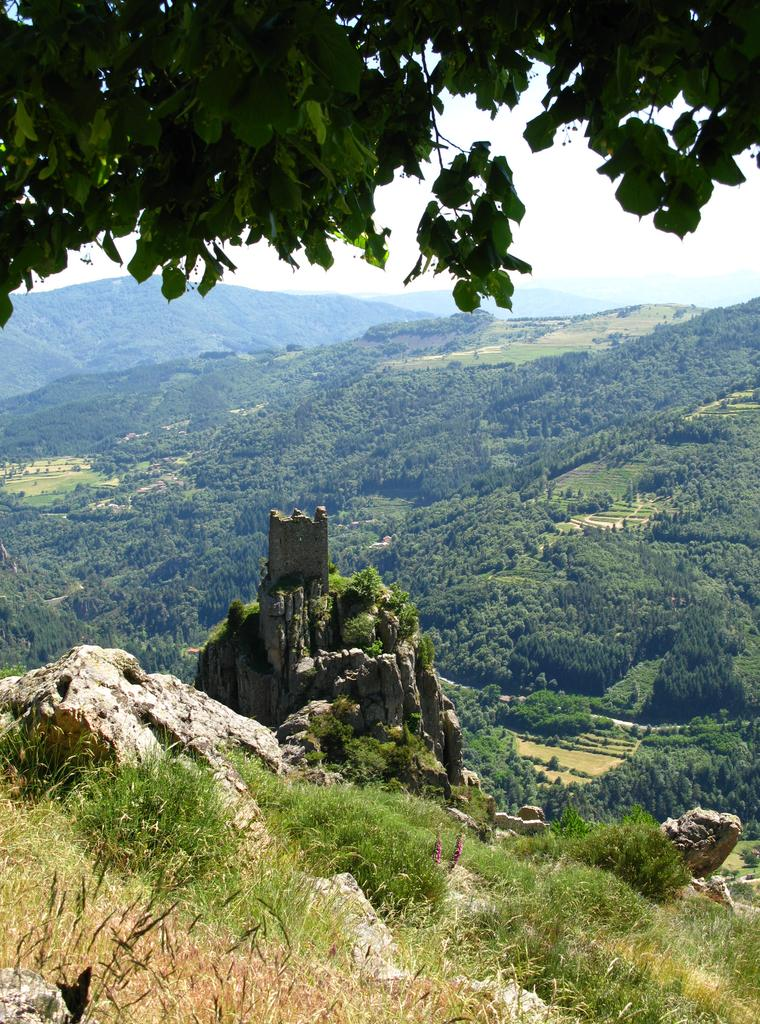What type of vegetation can be seen in the image? There is grass in the image. What geographical features are present in the image? There are hills in the image. What other natural elements can be seen in the image? There are trees in the image. What is visible in the background of the image? The sky is visible in the background of the image. What parts of the plants are visible at the top of the image? Leaves and stems are present at the top of the image. What type of business is being conducted in the image? There is no indication of any business activity in the image; it primarily features natural elements such as grass, hills, trees, and the sky. 